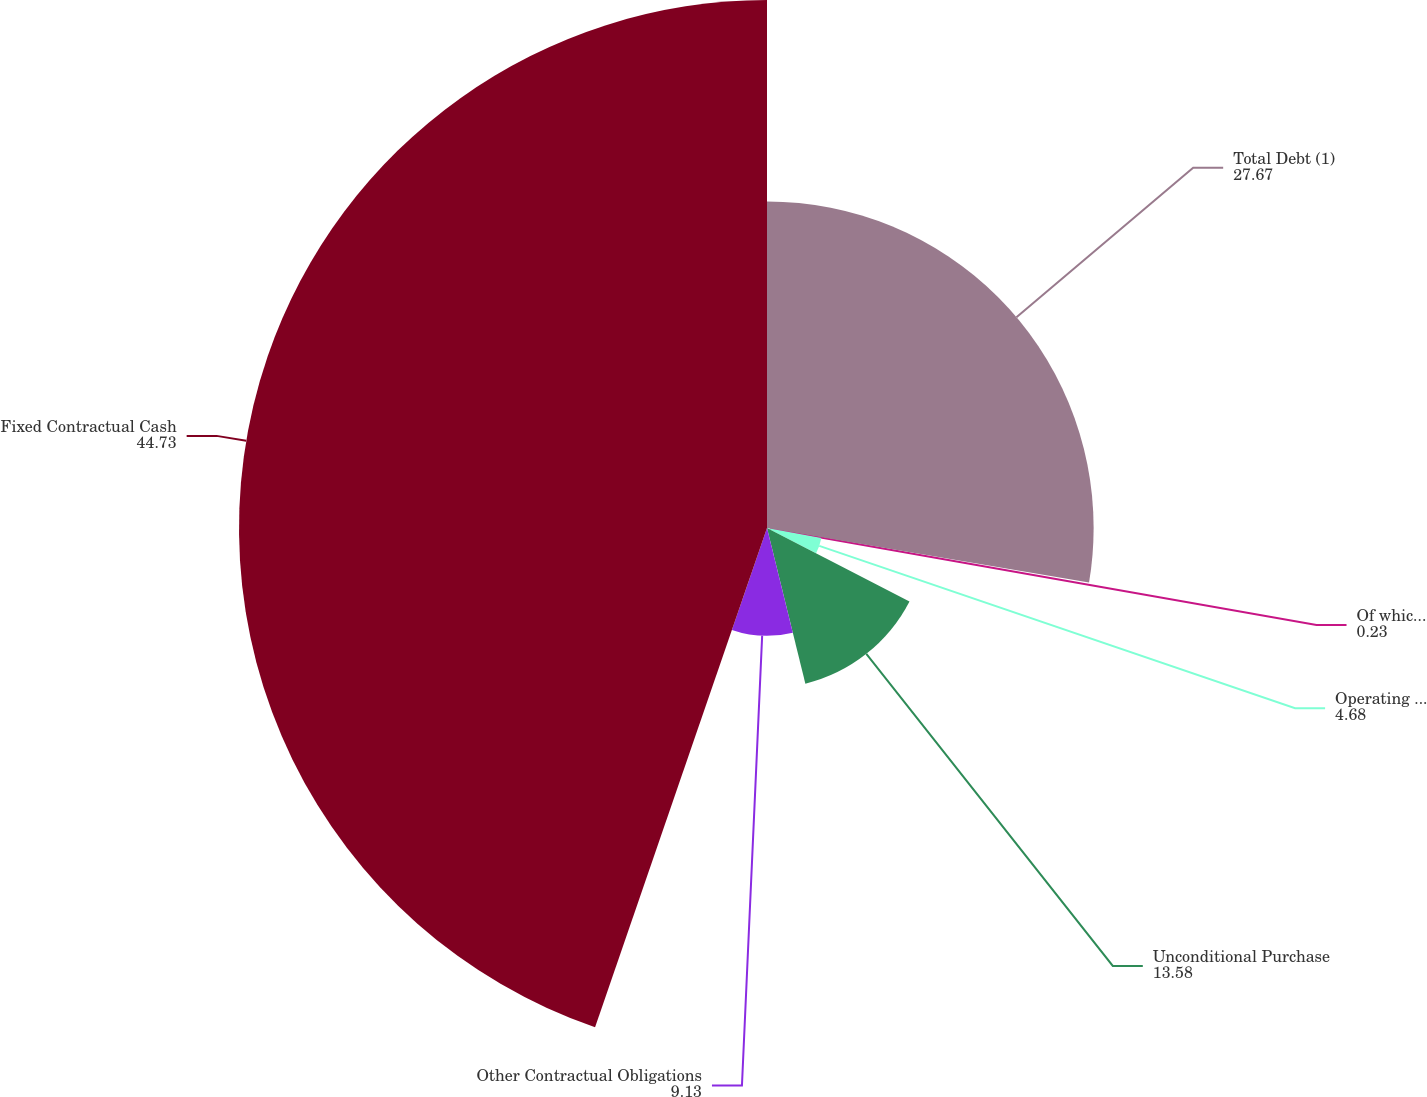<chart> <loc_0><loc_0><loc_500><loc_500><pie_chart><fcel>Total Debt (1)<fcel>Of which Capital Lease<fcel>Operating Leases<fcel>Unconditional Purchase<fcel>Other Contractual Obligations<fcel>Fixed Contractual Cash<nl><fcel>27.67%<fcel>0.23%<fcel>4.68%<fcel>13.58%<fcel>9.13%<fcel>44.73%<nl></chart> 